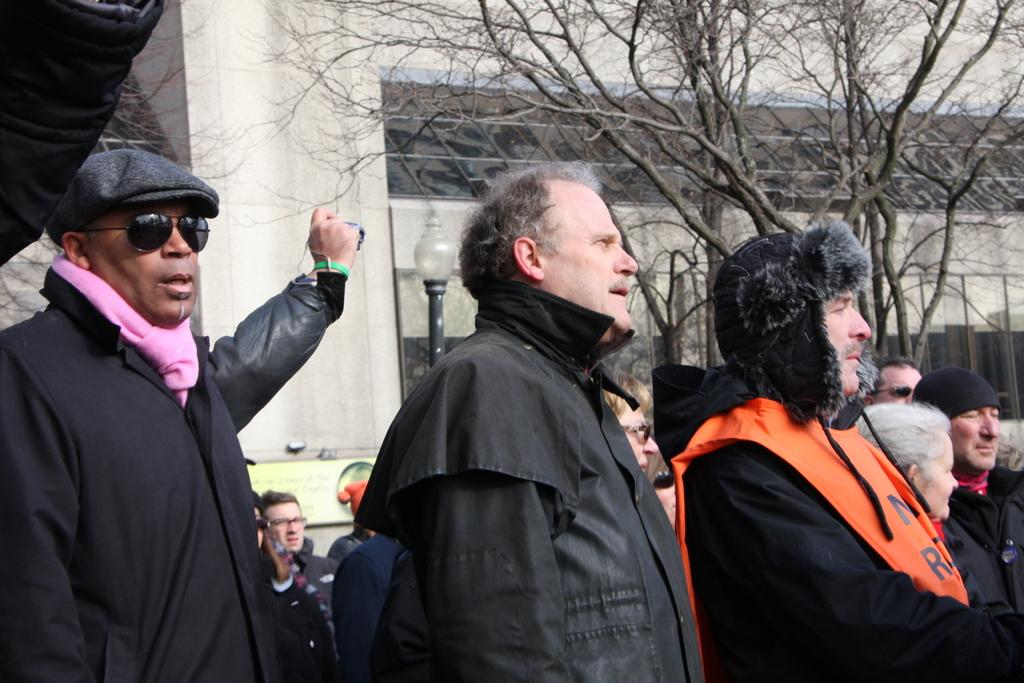How many persons are in black color dresses in the image? There are three persons in black color dresses in the image. What are the three persons in black color dresses doing? The three persons in black color dresses are standing. Can you describe the background of the image? There are other persons, trees, and buildings in the background of the image. What type of egg can be seen on the face of one of the persons in the image? There is no egg or face visible on any of the persons in the image. What type of shop is located near the persons in the image? There is no shop present in the image. 